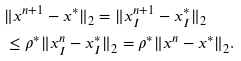<formula> <loc_0><loc_0><loc_500><loc_500>& \| x ^ { n + 1 } - x ^ { * } \| _ { 2 } = \| x _ { I } ^ { n + 1 } - x _ { I } ^ { * } \| _ { 2 } \\ & \leq \rho ^ { * } \| x _ { I } ^ { n } - x _ { I } ^ { * } \| _ { 2 } = \rho ^ { * } \| x ^ { n } - x ^ { * } \| _ { 2 } .</formula> 